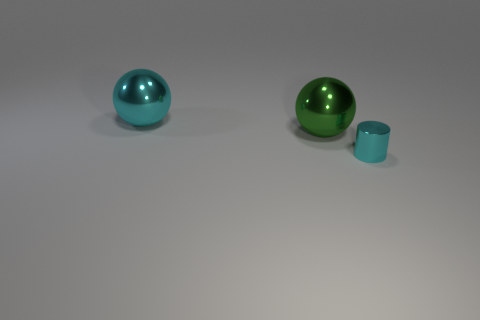Is the number of large things that are in front of the small cyan object less than the number of shiny cylinders?
Offer a terse response. Yes. Is the tiny cyan thing made of the same material as the large cyan object?
Provide a short and direct response. Yes. What number of things are either large green metallic things or cyan things?
Make the answer very short. 3. What number of green spheres are the same material as the cyan cylinder?
Give a very brief answer. 1. What size is the cyan object that is the same shape as the big green object?
Your answer should be very brief. Large. Are there any green metallic spheres in front of the green object?
Your answer should be very brief. No. What is the material of the green thing?
Make the answer very short. Metal. There is a shiny object that is to the left of the large green metal thing; is it the same color as the small cylinder?
Your answer should be compact. Yes. Is there anything else that has the same shape as the tiny metal thing?
Give a very brief answer. No. The other object that is the same shape as the big cyan thing is what color?
Your response must be concise. Green. 